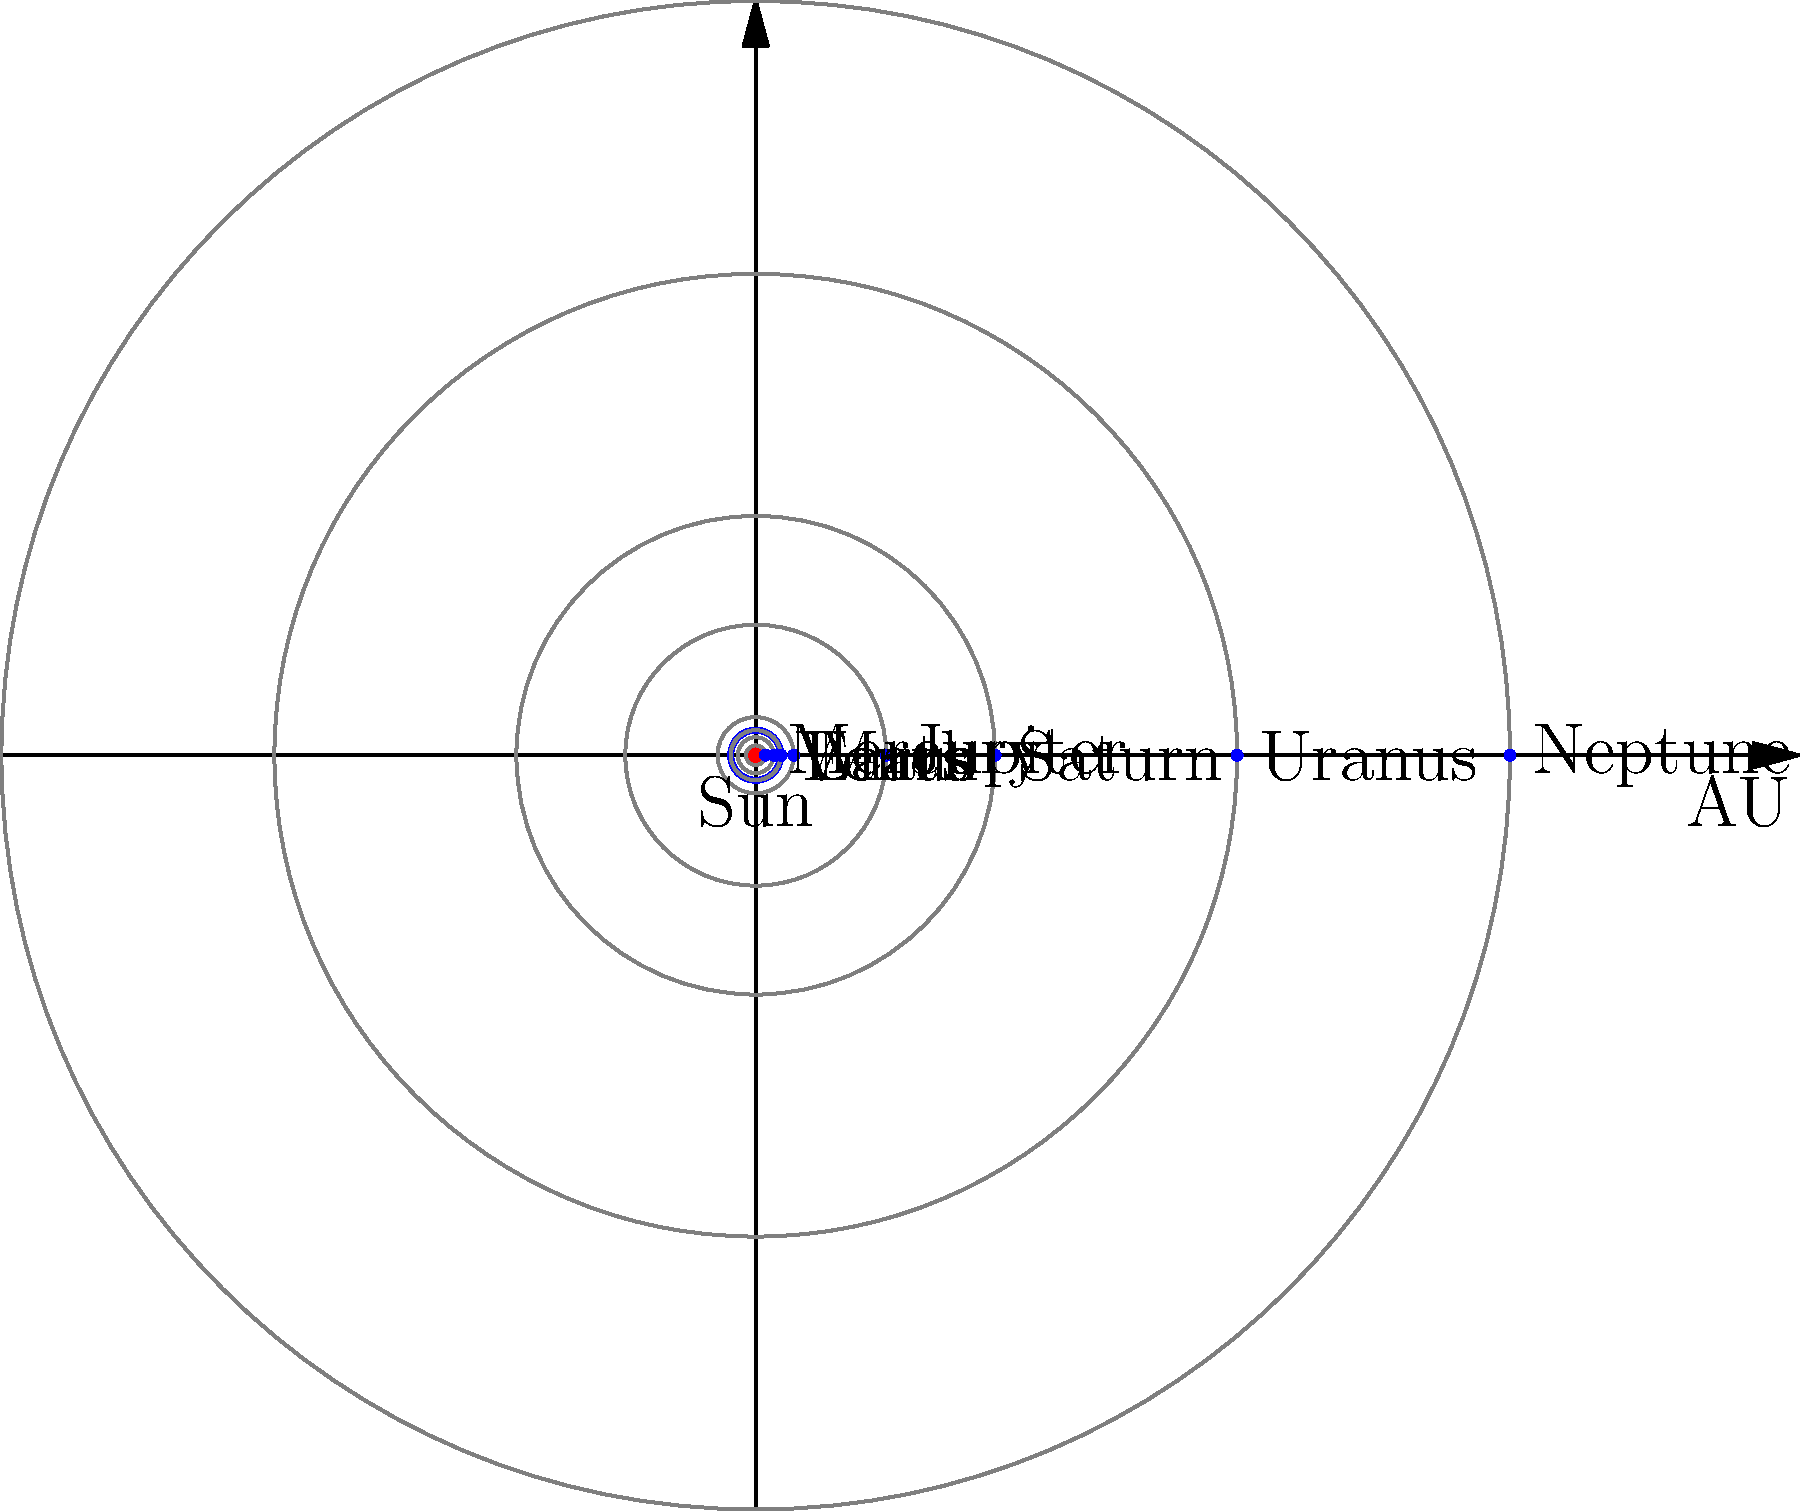In the context of tax law and public policy, consider the diagram representing the Solar System. If we were to implement a hypothetical "interplanetary tax" based on a planet's distance from the Sun, which planet would likely face the highest tax rate, and why might this be relevant to discussions about progressive taxation systems? To answer this question, we need to analyze the diagram and apply principles of progressive taxation:

1. The diagram shows the relative positions of planets in the Solar System, with their distances from the Sun measured in Astronomical Units (AU).

2. The planets, in order from closest to farthest from the Sun, are:
   Mercury, Venus, Earth, Mars, Jupiter, Saturn, Uranus, Neptune

3. In a progressive taxation system, tax rates typically increase as the taxable base increases. In this hypothetical scenario, the "taxable base" would be the distance from the Sun.

4. Neptune, being the farthest planet from the Sun, would have the largest "taxable base" and thus face the highest tax rate in this system.

5. This scenario is relevant to discussions about progressive taxation because:
   a) It illustrates the principle of increasing rates based on increasing values (distance in this case, income or wealth in real-world scenarios).
   b) It prompts consideration of whether such a system is fair or efficient, mirroring debates in terrestrial tax policy.
   c) It raises questions about the potential consequences of high tax rates on outlying entities (Neptune in this case, high-income earners or large corporations in real-world scenarios).

6. The analogy can be extended to discuss concepts like tax brackets, marginal rates, and the balance between revenue generation and potential disincentives created by high tax rates.

This hypothetical scenario provides a novel framework for examining progressive taxation principles, potentially offering fresh perspectives on earthbound tax policy debates.
Answer: Neptune; illustrates progressive taxation principles 